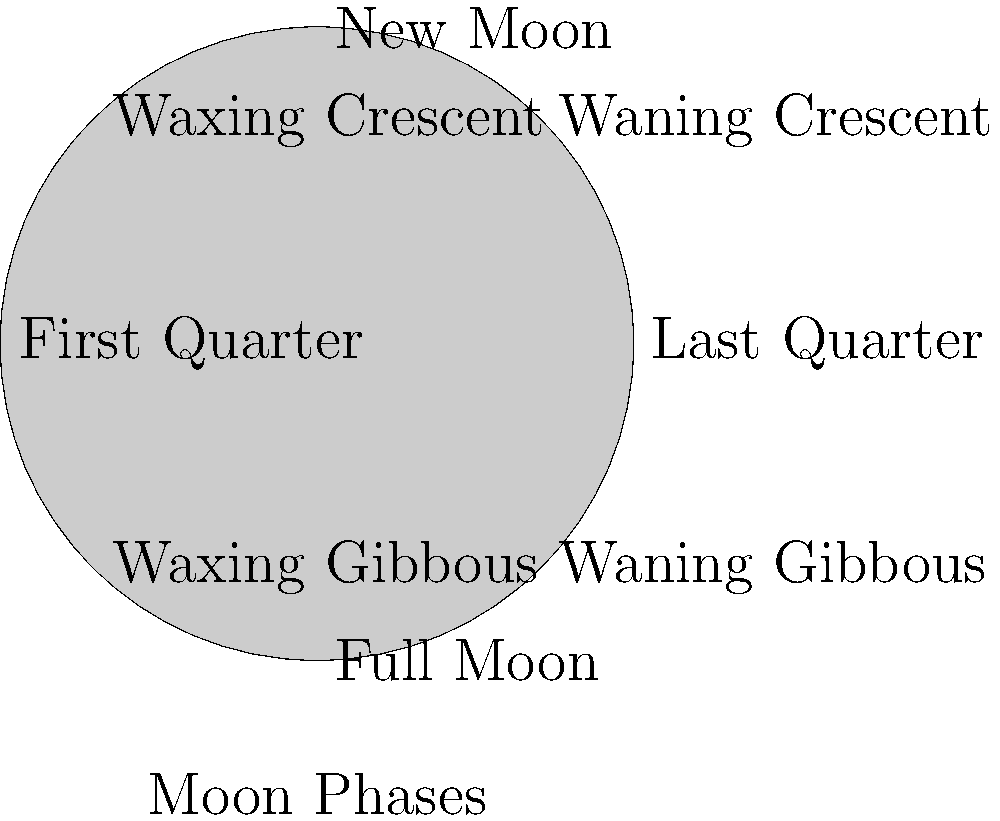In Armenian tradition, the waxing crescent moon is often associated with new beginnings and spiritual growth. How might this symbolism be incorporated into a progressive, inclusive church community, and what other cultural interpretations of this moon phase could enrich our understanding of diverse faith experiences? 1. Armenian symbolism: In Armenian tradition, the waxing crescent moon is seen as a symbol of new beginnings and spiritual growth. This aligns with the moon's visual appearance as it begins to grow from darkness into light.

2. Progressive church application: A progressive Armenian priest could use this symbolism to:
   a. Encourage personal growth and renewal among congregants
   b. Promote the idea of the church as an evolving, growing entity
   c. Introduce new, inclusive practices or ideas during this lunar phase

3. Inclusive approach: To create a more diverse church community, the priest could:
   a. Explore moon symbolism from other cultures
   b. Invite members from different backgrounds to share their lunar traditions
   c. Use these diverse perspectives to enrich spiritual discussions and practices

4. Other cultural interpretations:
   a. Islamic tradition: The crescent moon is a significant symbol in Islam, representing the beginning of a new month in the lunar calendar
   b. Hindu tradition: The waxing moon is associated with Soma, the god of the moon, and represents the growth of knowledge and wisdom
   c. Native American cultures: Many tribes view the waxing crescent as a time for setting intentions and beginning new projects

5. Enriching faith experiences:
   a. Combine these diverse interpretations to create a more holistic understanding of spiritual growth
   b. Use the various cultural meanings to illustrate the universality of seeking meaning in natural phenomena
   c. Develop interfaith dialogues and activities centered around shared lunar symbolism

6. Practical application:
   a. Organize monthly gatherings or rituals during the waxing crescent phase
   b. Encourage congregants to set personal or community goals aligned with the moon's symbolism
   c. Create art or music inspired by diverse cultural interpretations of the waxing crescent
Answer: Incorporate waxing crescent symbolism through monthly renewal practices, interfaith dialogues, and community goal-setting, while exploring diverse cultural interpretations to enrich spiritual understanding and promote inclusivity. 